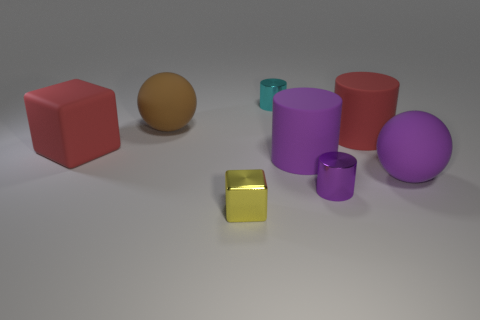Subtract all big purple matte cylinders. How many cylinders are left? 3 Subtract all brown blocks. How many purple cylinders are left? 2 Subtract all red cylinders. How many cylinders are left? 3 Subtract all blue cylinders. Subtract all yellow balls. How many cylinders are left? 4 Add 2 tiny metal cylinders. How many objects exist? 10 Subtract all cubes. How many objects are left? 6 Add 3 red cubes. How many red cubes are left? 4 Add 1 tiny yellow cubes. How many tiny yellow cubes exist? 2 Subtract 0 blue spheres. How many objects are left? 8 Subtract all purple rubber cylinders. Subtract all yellow cubes. How many objects are left? 6 